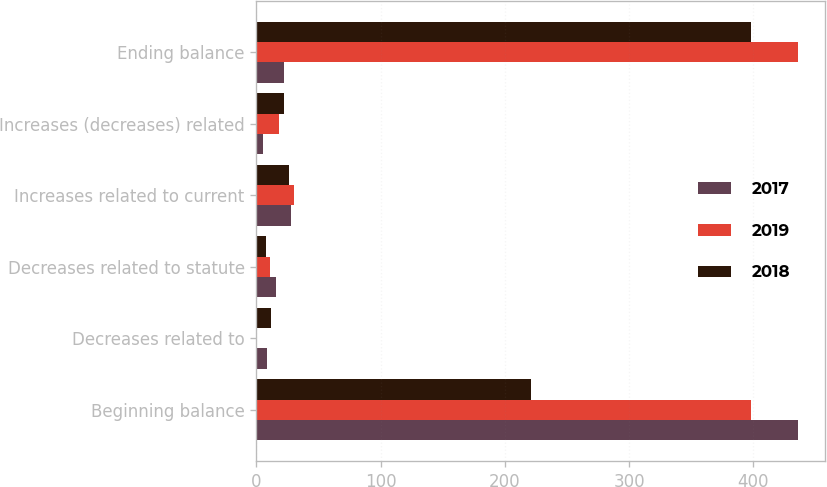Convert chart. <chart><loc_0><loc_0><loc_500><loc_500><stacked_bar_chart><ecel><fcel>Beginning balance<fcel>Decreases related to<fcel>Decreases related to statute<fcel>Increases related to current<fcel>Increases (decreases) related<fcel>Ending balance<nl><fcel>2017<fcel>436<fcel>8.3<fcel>16.2<fcel>27.8<fcel>5.6<fcel>22.5<nl><fcel>2019<fcel>398.5<fcel>0.1<fcel>10.9<fcel>30.3<fcel>18.2<fcel>436<nl><fcel>2018<fcel>220.7<fcel>11.7<fcel>7.6<fcel>26.3<fcel>22.5<fcel>398.5<nl></chart> 